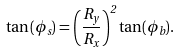<formula> <loc_0><loc_0><loc_500><loc_500>\tan ( \phi _ { s } ) = \left ( \frac { R _ { y } } { R _ { x } } \right ) ^ { 2 } \tan ( \phi _ { b } ) .</formula> 